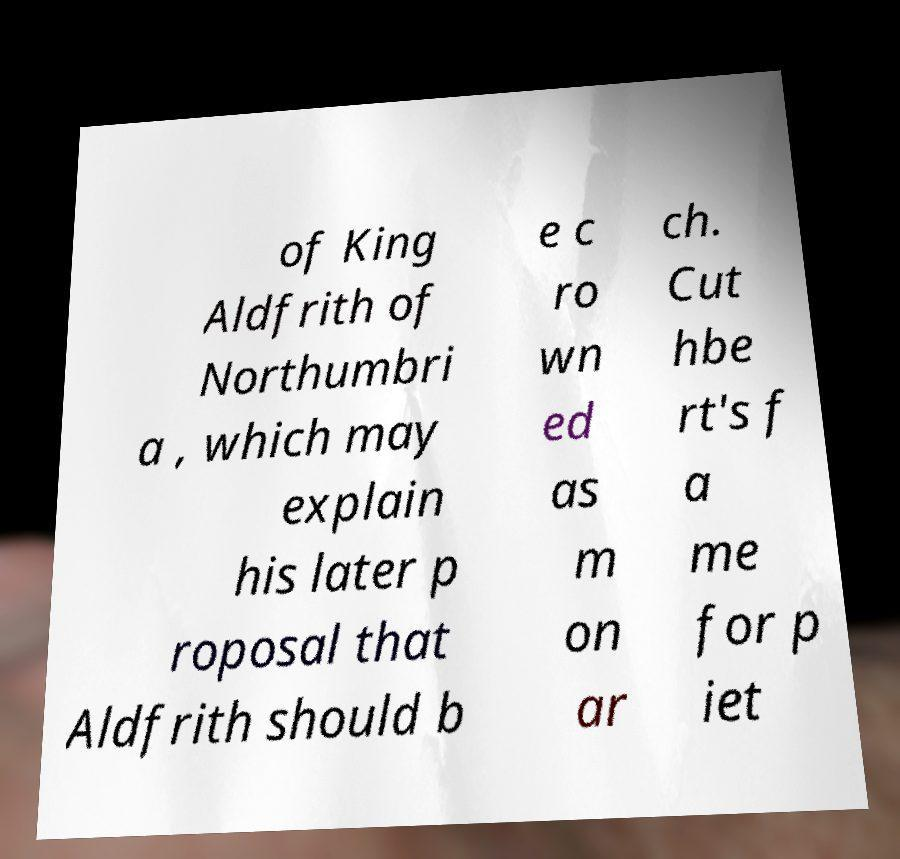Can you accurately transcribe the text from the provided image for me? of King Aldfrith of Northumbri a , which may explain his later p roposal that Aldfrith should b e c ro wn ed as m on ar ch. Cut hbe rt's f a me for p iet 